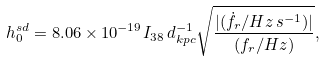Convert formula to latex. <formula><loc_0><loc_0><loc_500><loc_500>h _ { 0 } ^ { s d } = 8 . 0 6 \times 1 0 ^ { - 1 9 } I _ { 3 8 } \, d _ { k p c } ^ { - 1 } \sqrt { \frac { | ( \dot { f } _ { r } / H z \, s ^ { - 1 } ) | } { ( f _ { r } / H z ) } } ,</formula> 